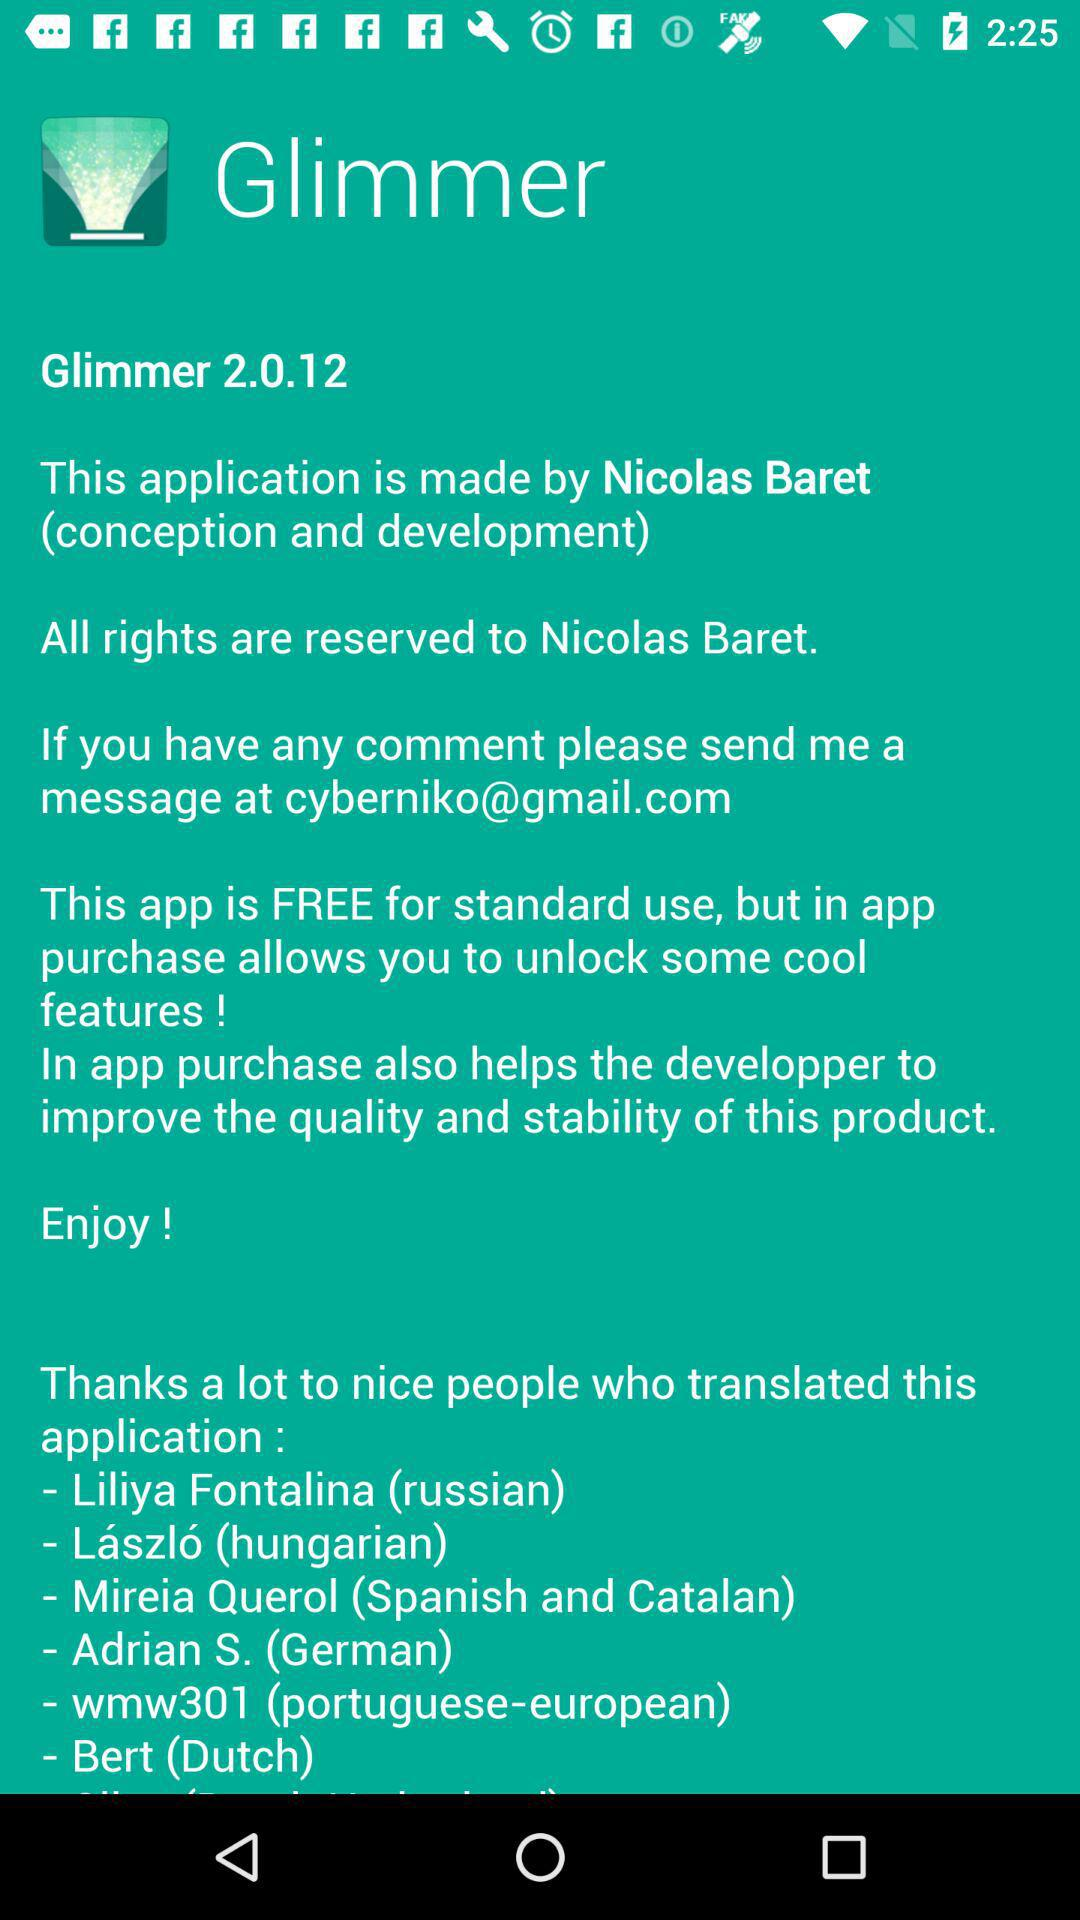What is the version of "Glimmer"? The version is 2.0.12. 